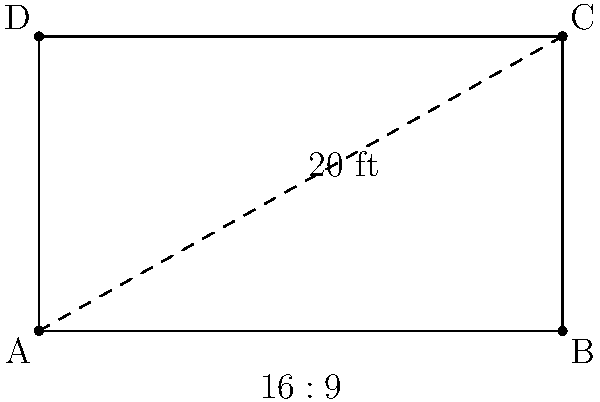At the Actors and Actresses Union Awards, you notice a rectangular movie screen with a diagonal length of 20 feet and an aspect ratio of 16:9. What is the width of the screen in feet? Let's approach this step-by-step:

1) First, let's define our variables:
   Let $w$ be the width and $h$ be the height of the screen.

2) We know that the aspect ratio is 16:9, so we can write:
   $\frac{w}{h} = \frac{16}{9}$

3) We can express the height in terms of the width:
   $h = \frac{9w}{16}$

4) Now, we can use the Pythagorean theorem. The diagonal ($d$) is 20 feet, so:
   $w^2 + h^2 = d^2$

5) Substituting our expression for $h$:
   $w^2 + (\frac{9w}{16})^2 = 20^2$

6) Simplify:
   $w^2 + \frac{81w^2}{256} = 400$

7) Combine like terms:
   $\frac{256w^2}{256} + \frac{81w^2}{256} = 400$
   $\frac{337w^2}{256} = 400$

8) Solve for $w$:
   $w^2 = \frac{400 * 256}{337}$
   $w = \sqrt{\frac{400 * 256}{337}} \approx 17.42$ feet

Therefore, the width of the screen is approximately 17.42 feet.
Answer: 17.42 feet 